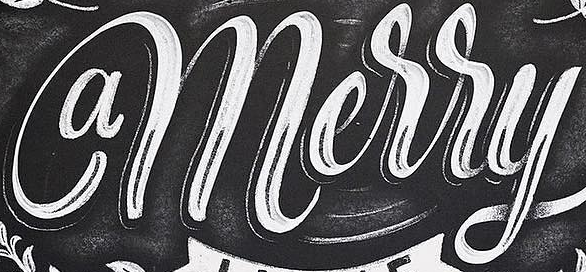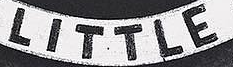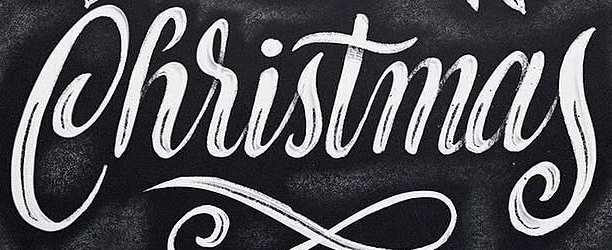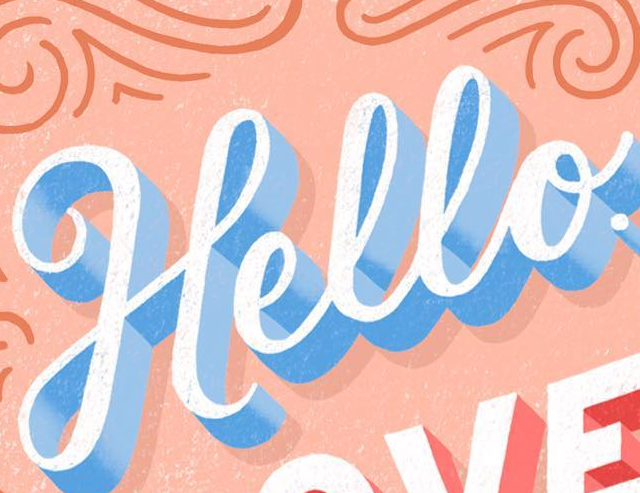Read the text content from these images in order, separated by a semicolon. amerry; LITTLE; Christmas; Hello 